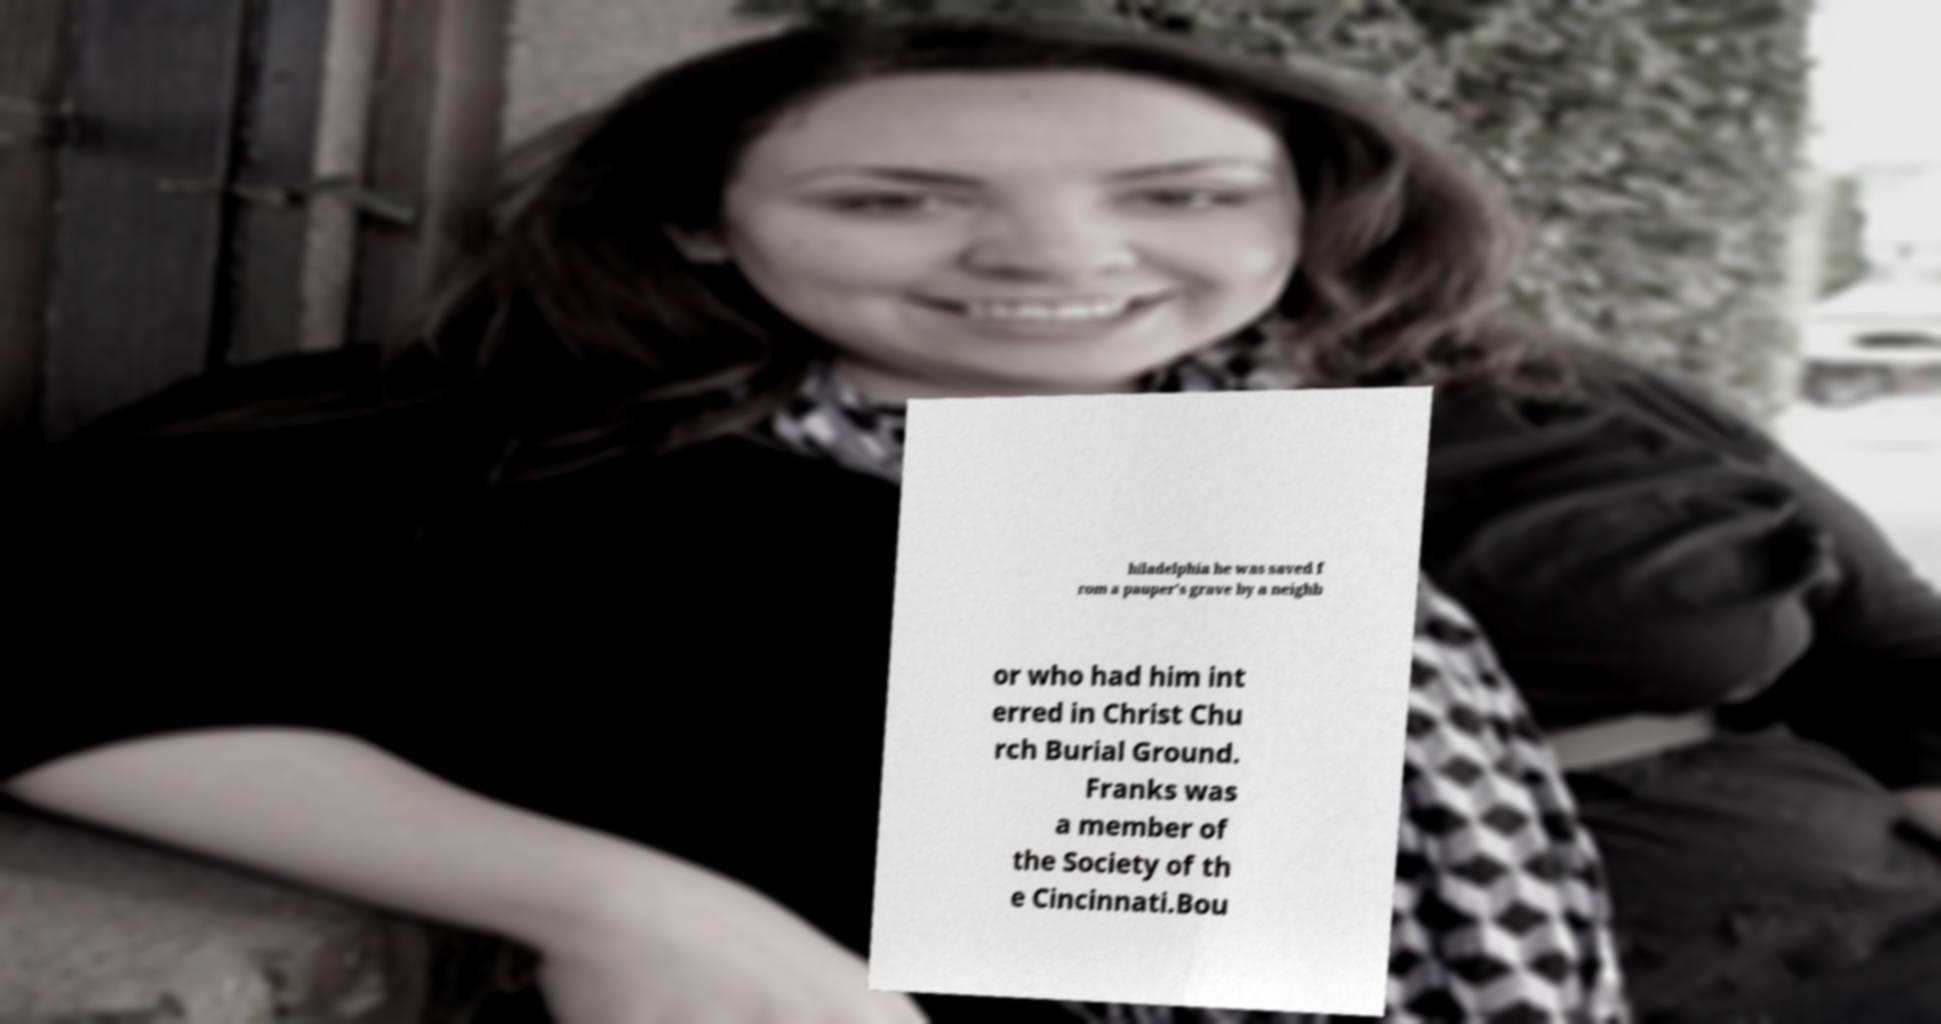There's text embedded in this image that I need extracted. Can you transcribe it verbatim? hiladelphia he was saved f rom a pauper's grave by a neighb or who had him int erred in Christ Chu rch Burial Ground. Franks was a member of the Society of th e Cincinnati.Bou 